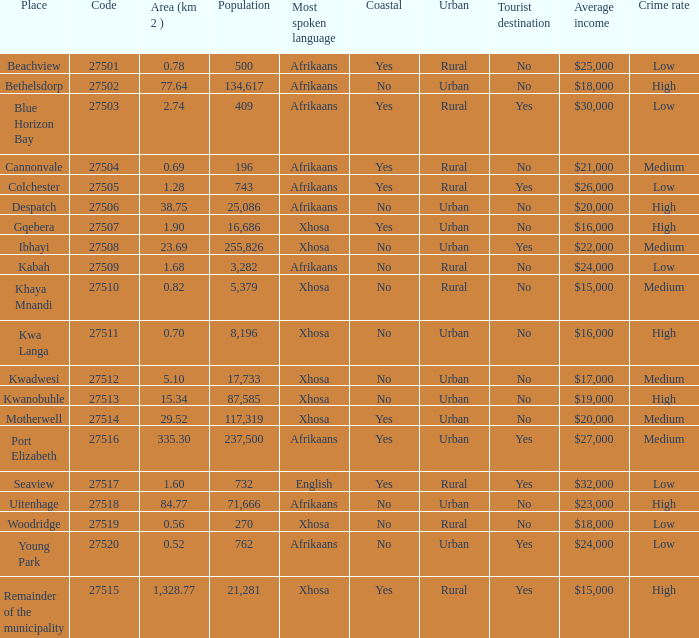What is the place that speaks xhosa, has a population less than 87,585, an area smaller than 1.28 squared kilometers, and a code larger than 27504? Khaya Mnandi, Kwa Langa, Woodridge. 